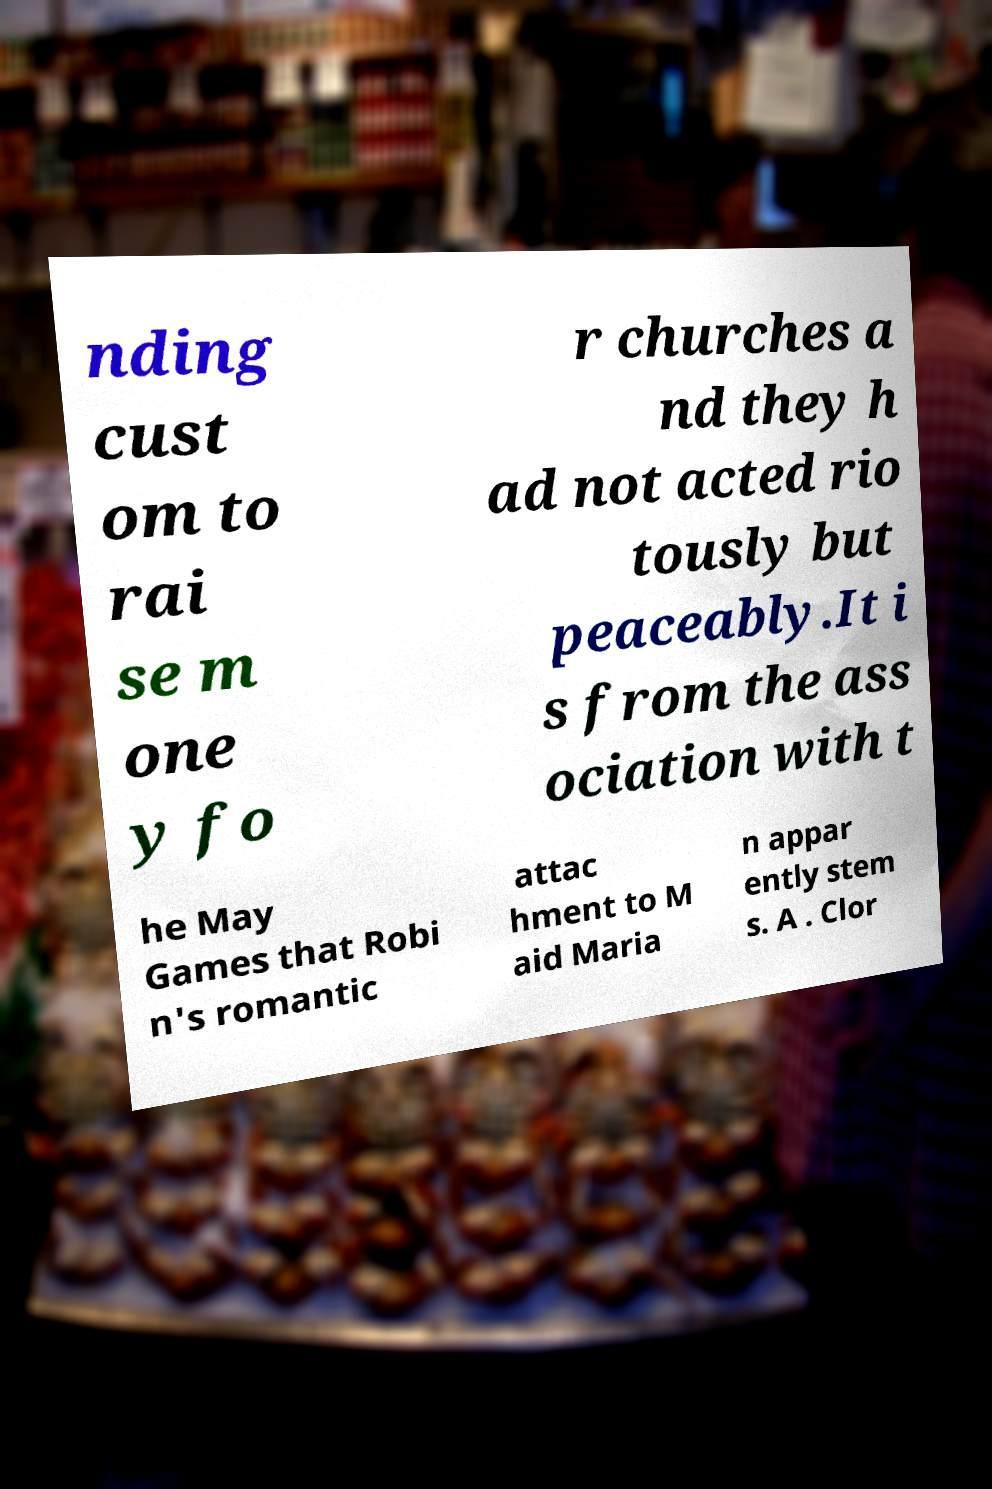I need the written content from this picture converted into text. Can you do that? nding cust om to rai se m one y fo r churches a nd they h ad not acted rio tously but peaceably.It i s from the ass ociation with t he May Games that Robi n's romantic attac hment to M aid Maria n appar ently stem s. A . Clor 